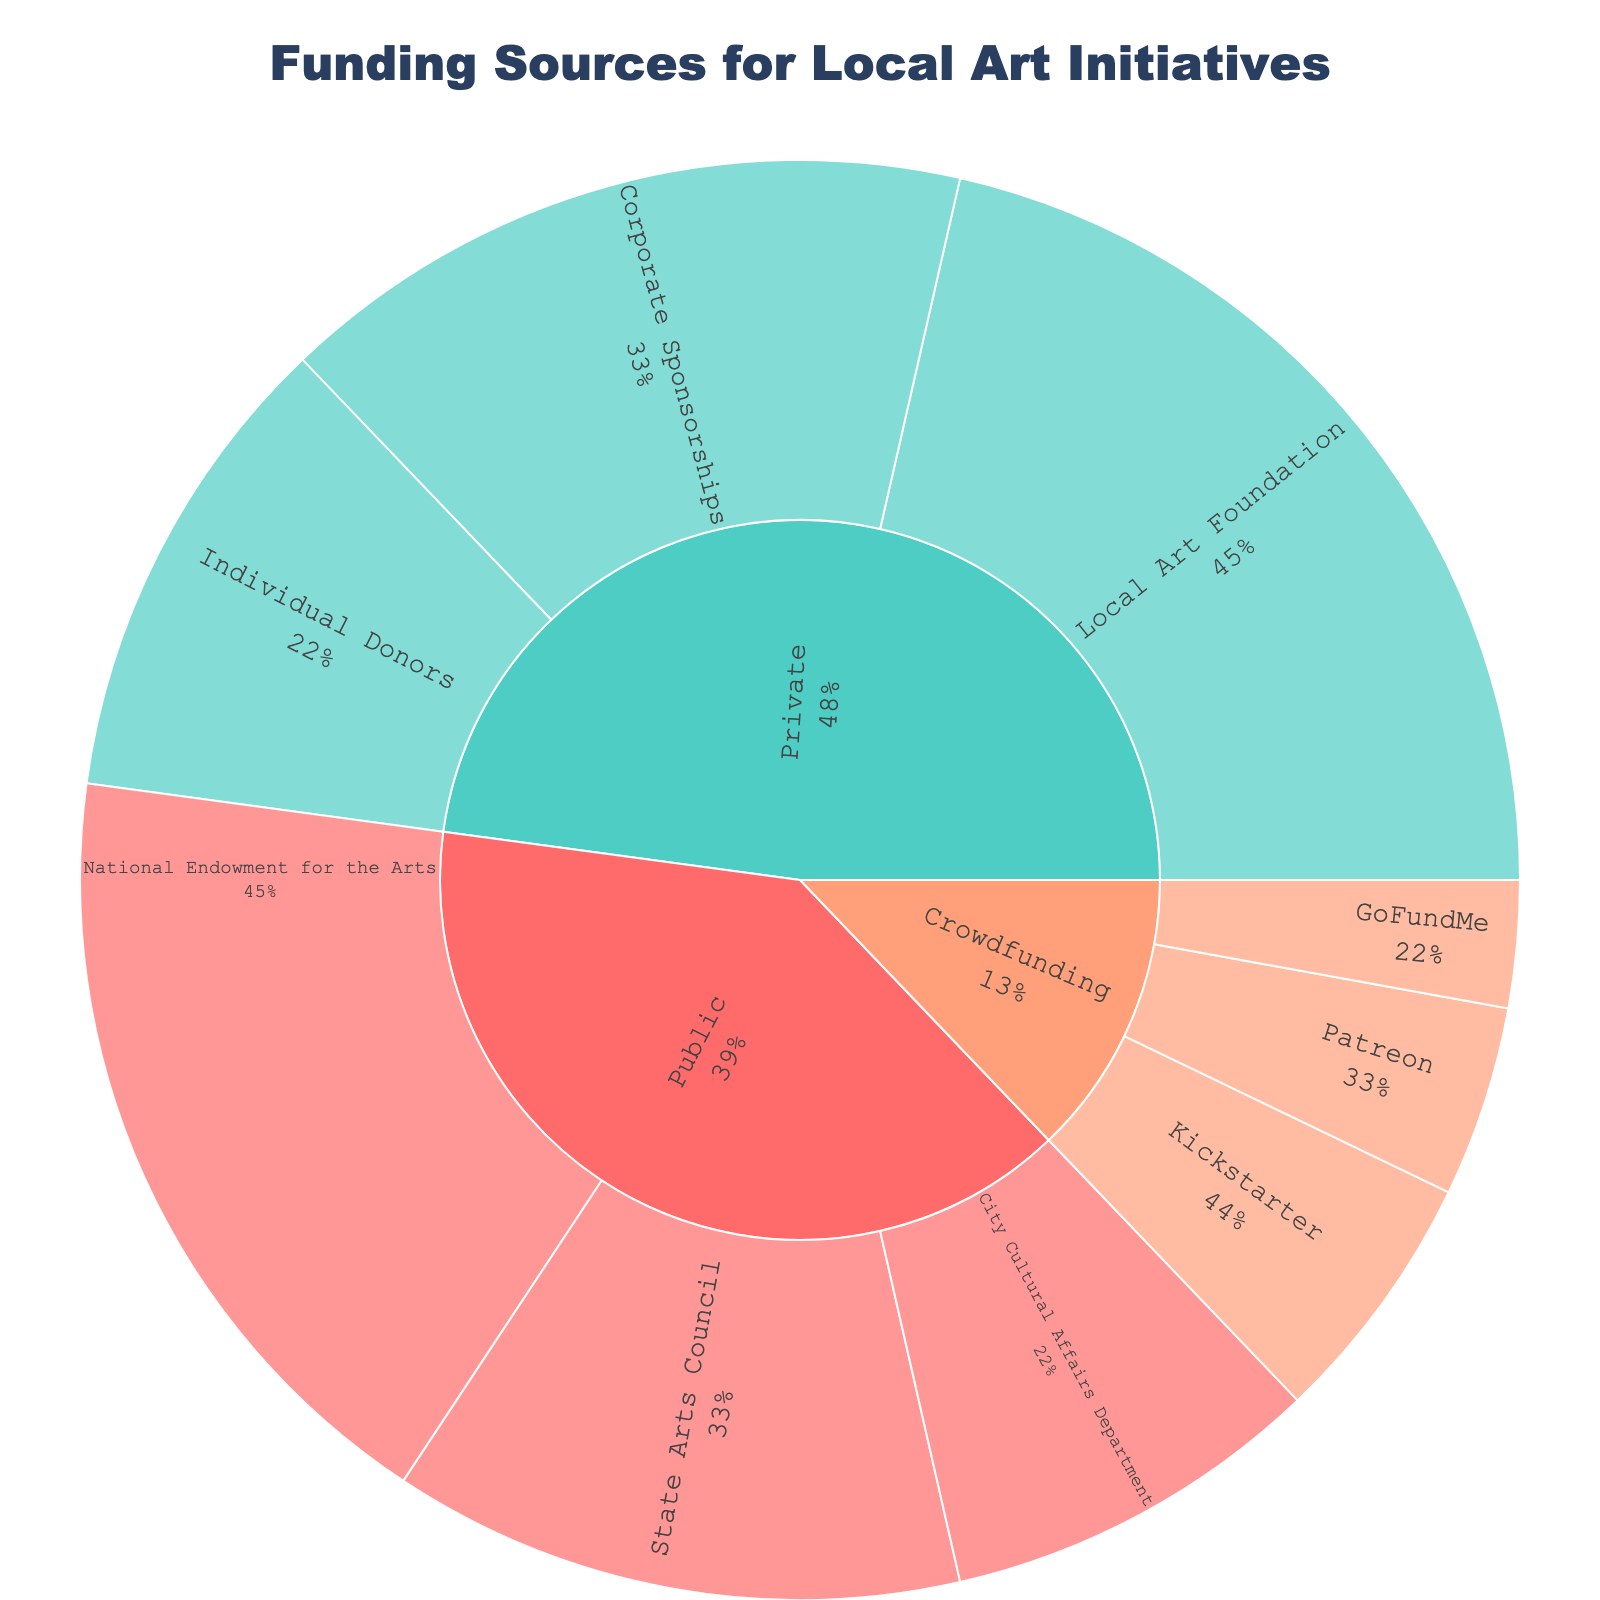What are the three main funding sources for local art initiatives? The sunburst plot has three main categories: Public, Private, and Crowdfunding.
Answer: Public, Private, Crowdfunding Which subcategory under "Private" has the highest contribution? Under the "Private" category, the subcategories are Local Art Foundation, Corporate Sponsorships, and Individual Donors. The Local Art Foundation has the highest contribution with $300,000.
Answer: Local Art Foundation How much funding comes from the National Endowment for the Arts? The National Endowment for the Arts is a subcategory under "Public." The value associated with it is $250,000.
Answer: $250,000 Compare the total amount of funding from Public and Crowdfunding sources. Which is higher and by how much? Sum the values for each category: Public (250,000 + 180,000 + 120,000 = 550,000) and Crowdfunding (80,000 + 60,000 + 40,000 = 180,000). The difference is 550,000 - 180,000 = 370,000. Public funding is higher by $370,000.
Answer: Public, $370,000 What is the total amount of funding received from Private sources? Sum the values from the "Private" category: 300,000 (Local Art Foundation) + 220,000 (Corporate Sponsorships) + 150,000 (Individual Donors) = 670,000.
Answer: $670,000 Which category contributes the least amount of funds, and what is that amount? Compare the total amounts for each category: Public ($550,000), Private ($670,000), Crowdfunding ($180,000). Crowdfunding has the least amount, which is $180,000.
Answer: Crowdfunding, $180,000 What percentage of the total funding is contributed by Corporate Sponsorships? The total funding amount from all categories is 1,400,000 (550,000 Public + 670,000 Private + 180,000 Crowdfunding). The percentage is (220,000 / 1,400,000) * 100 ≈ 15.71%.
Answer: ≈15.71% What is the combined total funding from Individual Donors and Kickstarter? Add the contributions from Individual Donors ($150,000) and Kickstarter ($80,000): 150,000 + 80,000 = 230,000.
Answer: $230,000 How does the funding amount for the State Arts Council compare to that from Patreon? The State Arts Council contributes $180,000, while Patreon contributes $60,000. Therefore, the State Arts Council contributes $120,000 more than Patreon.
Answer: $120,000 more Which subcategory has the smallest contribution, and how much is it? The smallest contribution among subcategories is from GoFundMe under Crowdfunding, which is $40,000.
Answer: GoFundMe, $40,000 